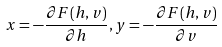<formula> <loc_0><loc_0><loc_500><loc_500>x = - \frac { \partial F ( h , v ) } { \partial h } , y = - \frac { \partial F ( h , v ) } { \partial v }</formula> 